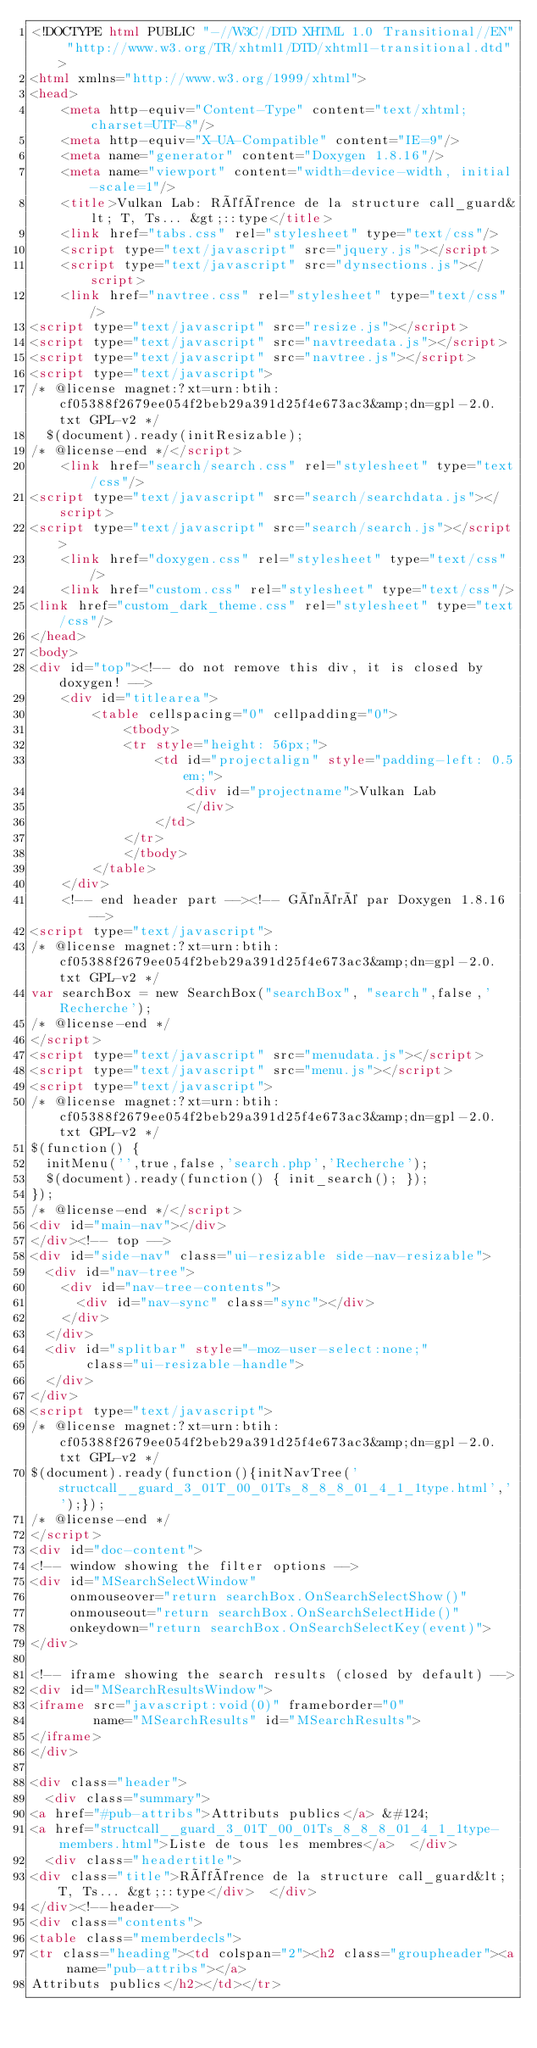<code> <loc_0><loc_0><loc_500><loc_500><_HTML_><!DOCTYPE html PUBLIC "-//W3C//DTD XHTML 1.0 Transitional//EN" "http://www.w3.org/TR/xhtml1/DTD/xhtml1-transitional.dtd">
<html xmlns="http://www.w3.org/1999/xhtml">
<head>
    <meta http-equiv="Content-Type" content="text/xhtml;charset=UTF-8"/>
    <meta http-equiv="X-UA-Compatible" content="IE=9"/>
    <meta name="generator" content="Doxygen 1.8.16"/>
    <meta name="viewport" content="width=device-width, initial-scale=1"/>
    <title>Vulkan Lab: Référence de la structure call_guard&lt; T, Ts... &gt;::type</title>
    <link href="tabs.css" rel="stylesheet" type="text/css"/>
    <script type="text/javascript" src="jquery.js"></script>
    <script type="text/javascript" src="dynsections.js"></script>
    <link href="navtree.css" rel="stylesheet" type="text/css"/>
<script type="text/javascript" src="resize.js"></script>
<script type="text/javascript" src="navtreedata.js"></script>
<script type="text/javascript" src="navtree.js"></script>
<script type="text/javascript">
/* @license magnet:?xt=urn:btih:cf05388f2679ee054f2beb29a391d25f4e673ac3&amp;dn=gpl-2.0.txt GPL-v2 */
  $(document).ready(initResizable);
/* @license-end */</script>
    <link href="search/search.css" rel="stylesheet" type="text/css"/>
<script type="text/javascript" src="search/searchdata.js"></script>
<script type="text/javascript" src="search/search.js"></script>
    <link href="doxygen.css" rel="stylesheet" type="text/css" />
    <link href="custom.css" rel="stylesheet" type="text/css"/>
<link href="custom_dark_theme.css" rel="stylesheet" type="text/css"/>
</head>
<body>
<div id="top"><!-- do not remove this div, it is closed by doxygen! -->
    <div id="titlearea">
        <table cellspacing="0" cellpadding="0">
            <tbody>
            <tr style="height: 56px;">
                <td id="projectalign" style="padding-left: 0.5em;">
                    <div id="projectname">Vulkan Lab
                    </div>
                </td>
            </tr>
            </tbody>
        </table>
    </div>
    <!-- end header part --><!-- Généré par Doxygen 1.8.16 -->
<script type="text/javascript">
/* @license magnet:?xt=urn:btih:cf05388f2679ee054f2beb29a391d25f4e673ac3&amp;dn=gpl-2.0.txt GPL-v2 */
var searchBox = new SearchBox("searchBox", "search",false,'Recherche');
/* @license-end */
</script>
<script type="text/javascript" src="menudata.js"></script>
<script type="text/javascript" src="menu.js"></script>
<script type="text/javascript">
/* @license magnet:?xt=urn:btih:cf05388f2679ee054f2beb29a391d25f4e673ac3&amp;dn=gpl-2.0.txt GPL-v2 */
$(function() {
  initMenu('',true,false,'search.php','Recherche');
  $(document).ready(function() { init_search(); });
});
/* @license-end */</script>
<div id="main-nav"></div>
</div><!-- top -->
<div id="side-nav" class="ui-resizable side-nav-resizable">
  <div id="nav-tree">
    <div id="nav-tree-contents">
      <div id="nav-sync" class="sync"></div>
    </div>
  </div>
  <div id="splitbar" style="-moz-user-select:none;" 
       class="ui-resizable-handle">
  </div>
</div>
<script type="text/javascript">
/* @license magnet:?xt=urn:btih:cf05388f2679ee054f2beb29a391d25f4e673ac3&amp;dn=gpl-2.0.txt GPL-v2 */
$(document).ready(function(){initNavTree('structcall__guard_3_01T_00_01Ts_8_8_8_01_4_1_1type.html','');});
/* @license-end */
</script>
<div id="doc-content">
<!-- window showing the filter options -->
<div id="MSearchSelectWindow"
     onmouseover="return searchBox.OnSearchSelectShow()"
     onmouseout="return searchBox.OnSearchSelectHide()"
     onkeydown="return searchBox.OnSearchSelectKey(event)">
</div>

<!-- iframe showing the search results (closed by default) -->
<div id="MSearchResultsWindow">
<iframe src="javascript:void(0)" frameborder="0" 
        name="MSearchResults" id="MSearchResults">
</iframe>
</div>

<div class="header">
  <div class="summary">
<a href="#pub-attribs">Attributs publics</a> &#124;
<a href="structcall__guard_3_01T_00_01Ts_8_8_8_01_4_1_1type-members.html">Liste de tous les membres</a>  </div>
  <div class="headertitle">
<div class="title">Référence de la structure call_guard&lt; T, Ts... &gt;::type</div>  </div>
</div><!--header-->
<div class="contents">
<table class="memberdecls">
<tr class="heading"><td colspan="2"><h2 class="groupheader"><a name="pub-attribs"></a>
Attributs publics</h2></td></tr></code> 